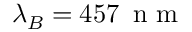Convert formula to latex. <formula><loc_0><loc_0><loc_500><loc_500>\lambda _ { B } = 4 5 7 \, n m</formula> 